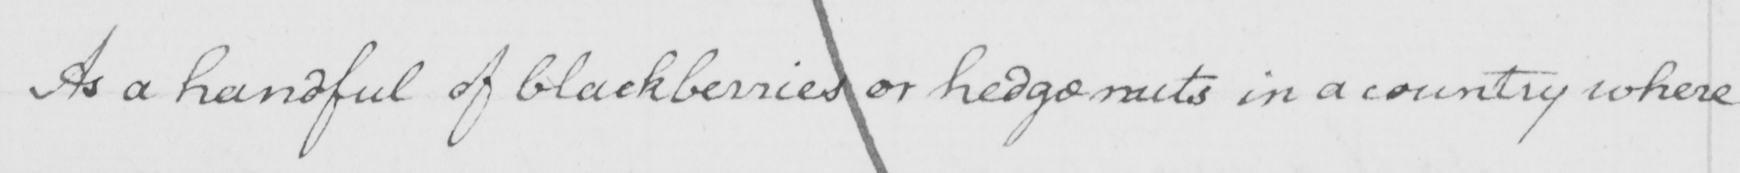Please transcribe the handwritten text in this image. As a handful of blackberries or hedgenuts in a country where 